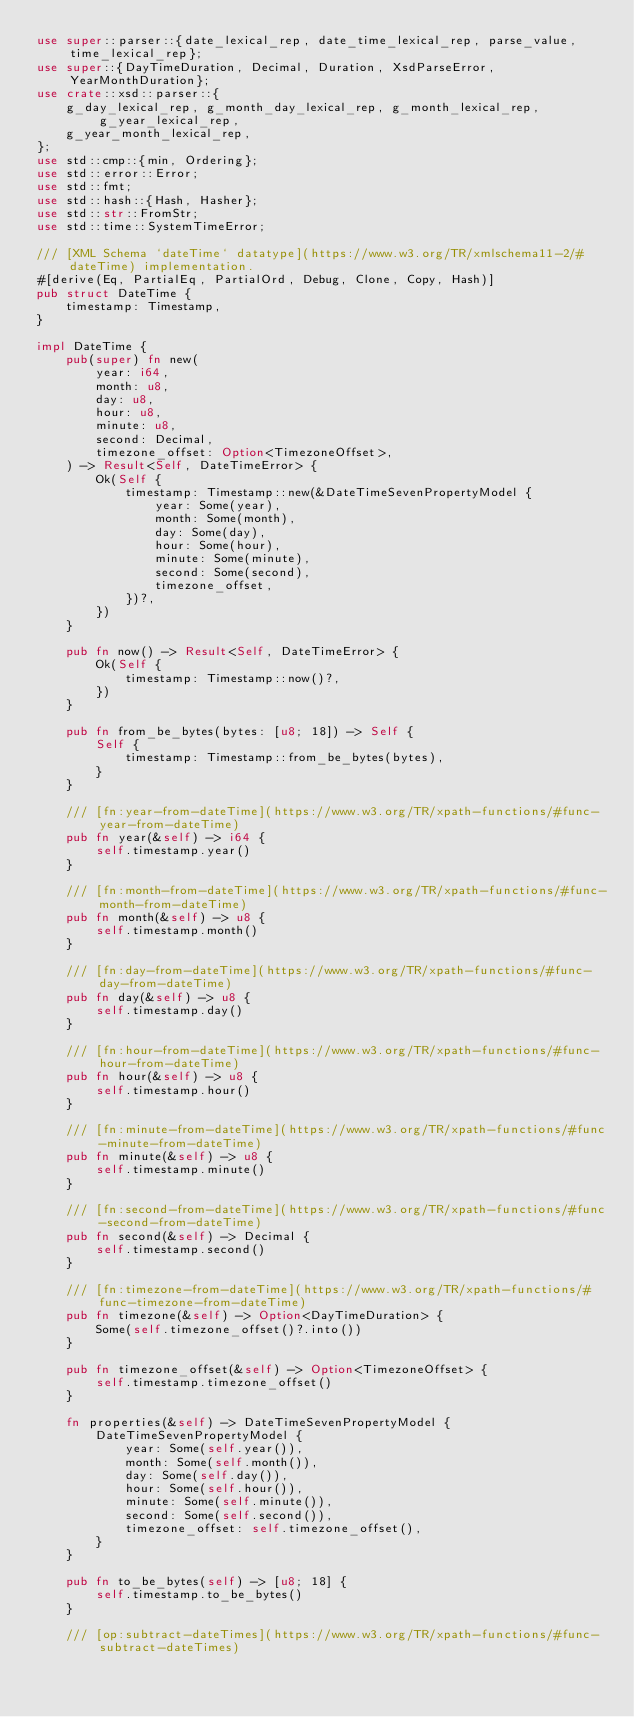<code> <loc_0><loc_0><loc_500><loc_500><_Rust_>use super::parser::{date_lexical_rep, date_time_lexical_rep, parse_value, time_lexical_rep};
use super::{DayTimeDuration, Decimal, Duration, XsdParseError, YearMonthDuration};
use crate::xsd::parser::{
    g_day_lexical_rep, g_month_day_lexical_rep, g_month_lexical_rep, g_year_lexical_rep,
    g_year_month_lexical_rep,
};
use std::cmp::{min, Ordering};
use std::error::Error;
use std::fmt;
use std::hash::{Hash, Hasher};
use std::str::FromStr;
use std::time::SystemTimeError;

/// [XML Schema `dateTime` datatype](https://www.w3.org/TR/xmlschema11-2/#dateTime) implementation.
#[derive(Eq, PartialEq, PartialOrd, Debug, Clone, Copy, Hash)]
pub struct DateTime {
    timestamp: Timestamp,
}

impl DateTime {
    pub(super) fn new(
        year: i64,
        month: u8,
        day: u8,
        hour: u8,
        minute: u8,
        second: Decimal,
        timezone_offset: Option<TimezoneOffset>,
    ) -> Result<Self, DateTimeError> {
        Ok(Self {
            timestamp: Timestamp::new(&DateTimeSevenPropertyModel {
                year: Some(year),
                month: Some(month),
                day: Some(day),
                hour: Some(hour),
                minute: Some(minute),
                second: Some(second),
                timezone_offset,
            })?,
        })
    }

    pub fn now() -> Result<Self, DateTimeError> {
        Ok(Self {
            timestamp: Timestamp::now()?,
        })
    }

    pub fn from_be_bytes(bytes: [u8; 18]) -> Self {
        Self {
            timestamp: Timestamp::from_be_bytes(bytes),
        }
    }

    /// [fn:year-from-dateTime](https://www.w3.org/TR/xpath-functions/#func-year-from-dateTime)
    pub fn year(&self) -> i64 {
        self.timestamp.year()
    }

    /// [fn:month-from-dateTime](https://www.w3.org/TR/xpath-functions/#func-month-from-dateTime)
    pub fn month(&self) -> u8 {
        self.timestamp.month()
    }

    /// [fn:day-from-dateTime](https://www.w3.org/TR/xpath-functions/#func-day-from-dateTime)
    pub fn day(&self) -> u8 {
        self.timestamp.day()
    }

    /// [fn:hour-from-dateTime](https://www.w3.org/TR/xpath-functions/#func-hour-from-dateTime)
    pub fn hour(&self) -> u8 {
        self.timestamp.hour()
    }

    /// [fn:minute-from-dateTime](https://www.w3.org/TR/xpath-functions/#func-minute-from-dateTime)
    pub fn minute(&self) -> u8 {
        self.timestamp.minute()
    }

    /// [fn:second-from-dateTime](https://www.w3.org/TR/xpath-functions/#func-second-from-dateTime)
    pub fn second(&self) -> Decimal {
        self.timestamp.second()
    }

    /// [fn:timezone-from-dateTime](https://www.w3.org/TR/xpath-functions/#func-timezone-from-dateTime)
    pub fn timezone(&self) -> Option<DayTimeDuration> {
        Some(self.timezone_offset()?.into())
    }

    pub fn timezone_offset(&self) -> Option<TimezoneOffset> {
        self.timestamp.timezone_offset()
    }

    fn properties(&self) -> DateTimeSevenPropertyModel {
        DateTimeSevenPropertyModel {
            year: Some(self.year()),
            month: Some(self.month()),
            day: Some(self.day()),
            hour: Some(self.hour()),
            minute: Some(self.minute()),
            second: Some(self.second()),
            timezone_offset: self.timezone_offset(),
        }
    }

    pub fn to_be_bytes(self) -> [u8; 18] {
        self.timestamp.to_be_bytes()
    }

    /// [op:subtract-dateTimes](https://www.w3.org/TR/xpath-functions/#func-subtract-dateTimes)</code> 